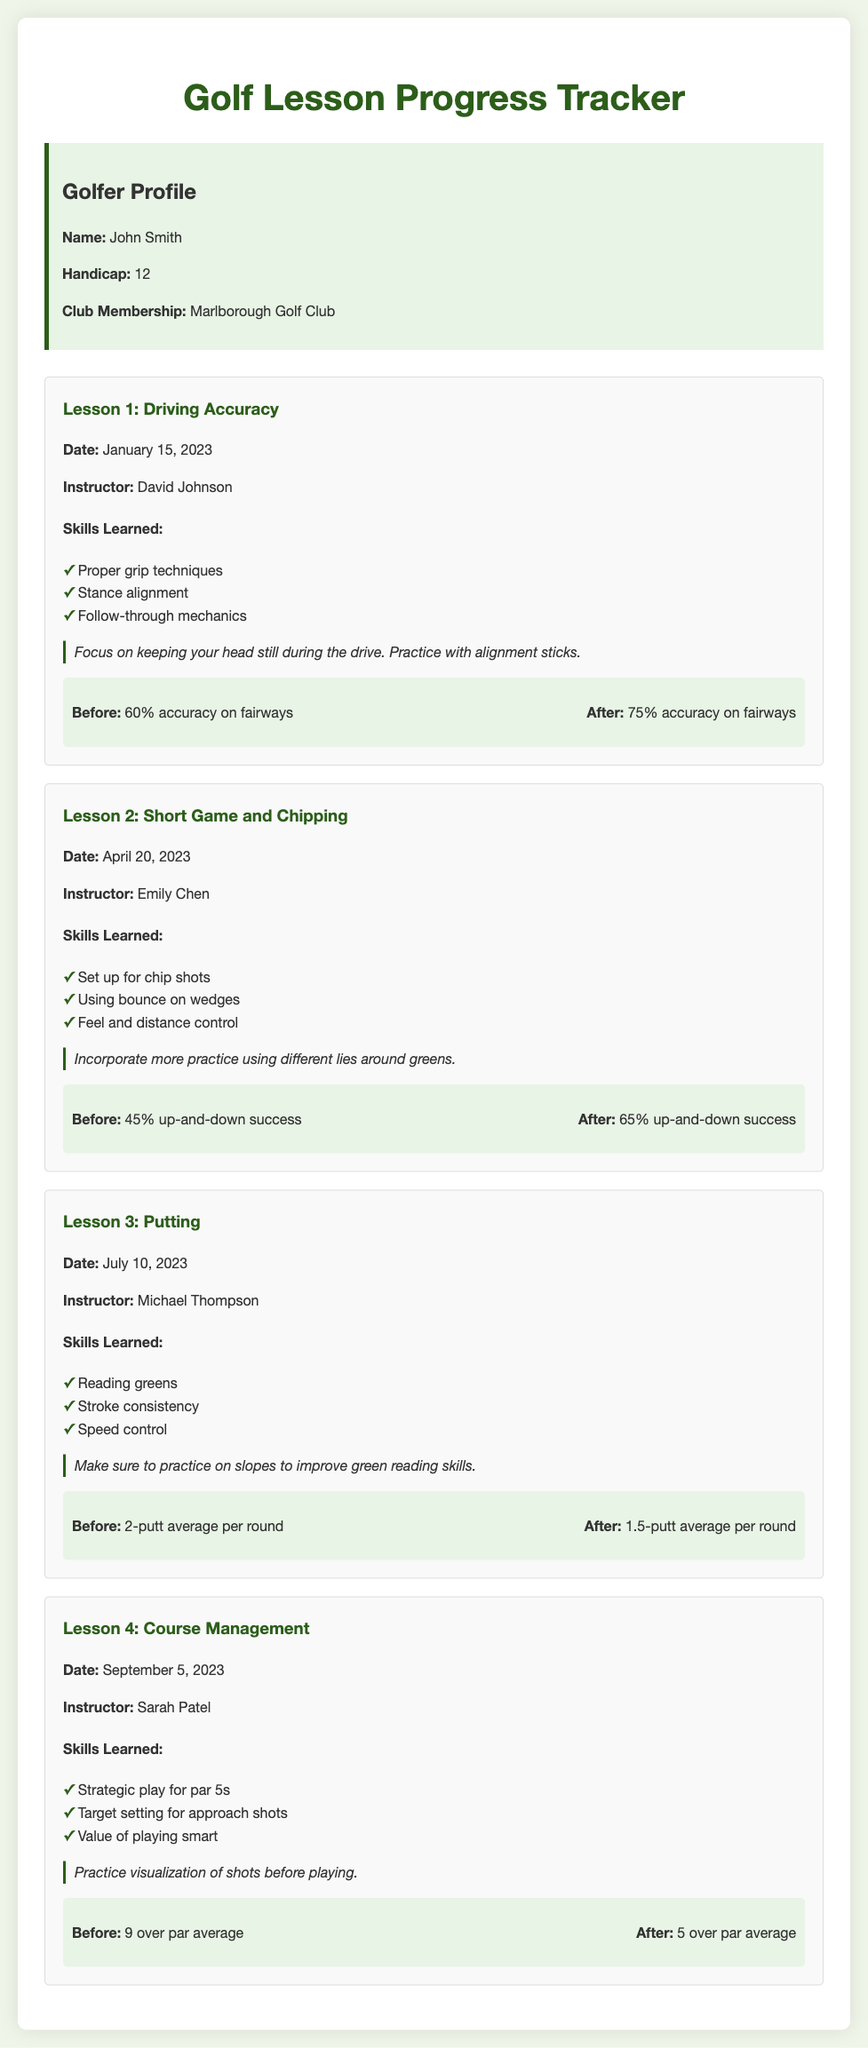What is the name of the golfer? The name of the golfer is provided in the golfer profile section of the document.
Answer: John Smith What is the handicap of the golfer? The handicap is indicated in the golfer profile section.
Answer: 12 Who was the instructor for Lesson 2? The instructor's name for Lesson 2 is mentioned in the lesson details.
Answer: Emily Chen What skill was learned in Lesson 3? The document lists the skills learned in each lesson; one skill for Lesson 3 is required for this question.
Answer: Reading greens What was the percentage increase in driving accuracy after Lesson 1? The performance section of Lesson 1 provides the before and after statistics, allowing for calculation of the increase.
Answer: 15% What is the date of Lesson 4? The date for each lesson is listed under the respective lesson heading.
Answer: September 5, 2023 What change occurred in the up-and-down success rate from Lesson 2? The performance statistics before and after Lesson 2 are provided, indicating what the success rate changed to.
Answer: 20% What is a focus point noted in the instructor notes for Lesson 1? Instructor notes reflect teaching points for each lesson; an example can be taken from Lesson 1.
Answer: Keep your head still during the drive What was the before and after average putt count in Lesson 3? The performance section notes the average putts per round before and after Lesson 3, providing a direct comparison.
Answer: 2-putt average per round, 1.5-putt average per round 